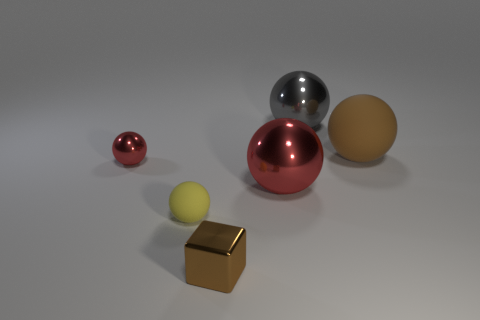Subtract all large gray spheres. How many spheres are left? 4 Subtract all purple blocks. How many red balls are left? 2 Add 1 yellow balls. How many objects exist? 7 Subtract all red balls. How many balls are left? 3 Subtract 1 balls. How many balls are left? 4 Subtract all spheres. How many objects are left? 1 Add 3 large red shiny balls. How many large red shiny balls exist? 4 Subtract 0 purple cylinders. How many objects are left? 6 Subtract all green balls. Subtract all blue cylinders. How many balls are left? 5 Subtract all small yellow rubber things. Subtract all big red metallic things. How many objects are left? 4 